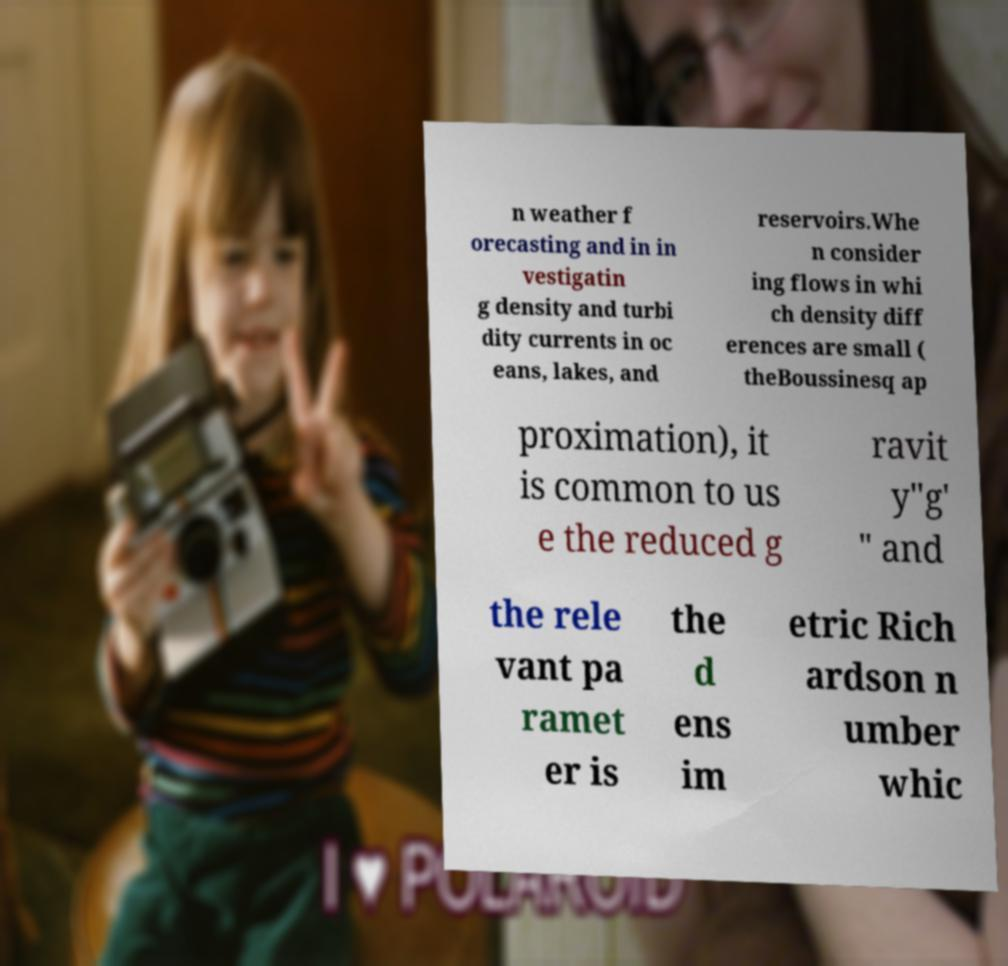Please identify and transcribe the text found in this image. n weather f orecasting and in in vestigatin g density and turbi dity currents in oc eans, lakes, and reservoirs.Whe n consider ing flows in whi ch density diff erences are small ( theBoussinesq ap proximation), it is common to us e the reduced g ravit y"g' " and the rele vant pa ramet er is the d ens im etric Rich ardson n umber whic 